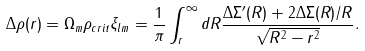<formula> <loc_0><loc_0><loc_500><loc_500>\Delta \rho ( r ) = \Omega _ { m } \rho _ { c r i t } \xi _ { l m } = \frac { 1 } { \pi } \int _ { r } ^ { \infty } d R \frac { \Delta \Sigma ^ { \prime } ( R ) + 2 \Delta \Sigma ( R ) / R } { \sqrt { R ^ { 2 } - r ^ { 2 } } } .</formula> 